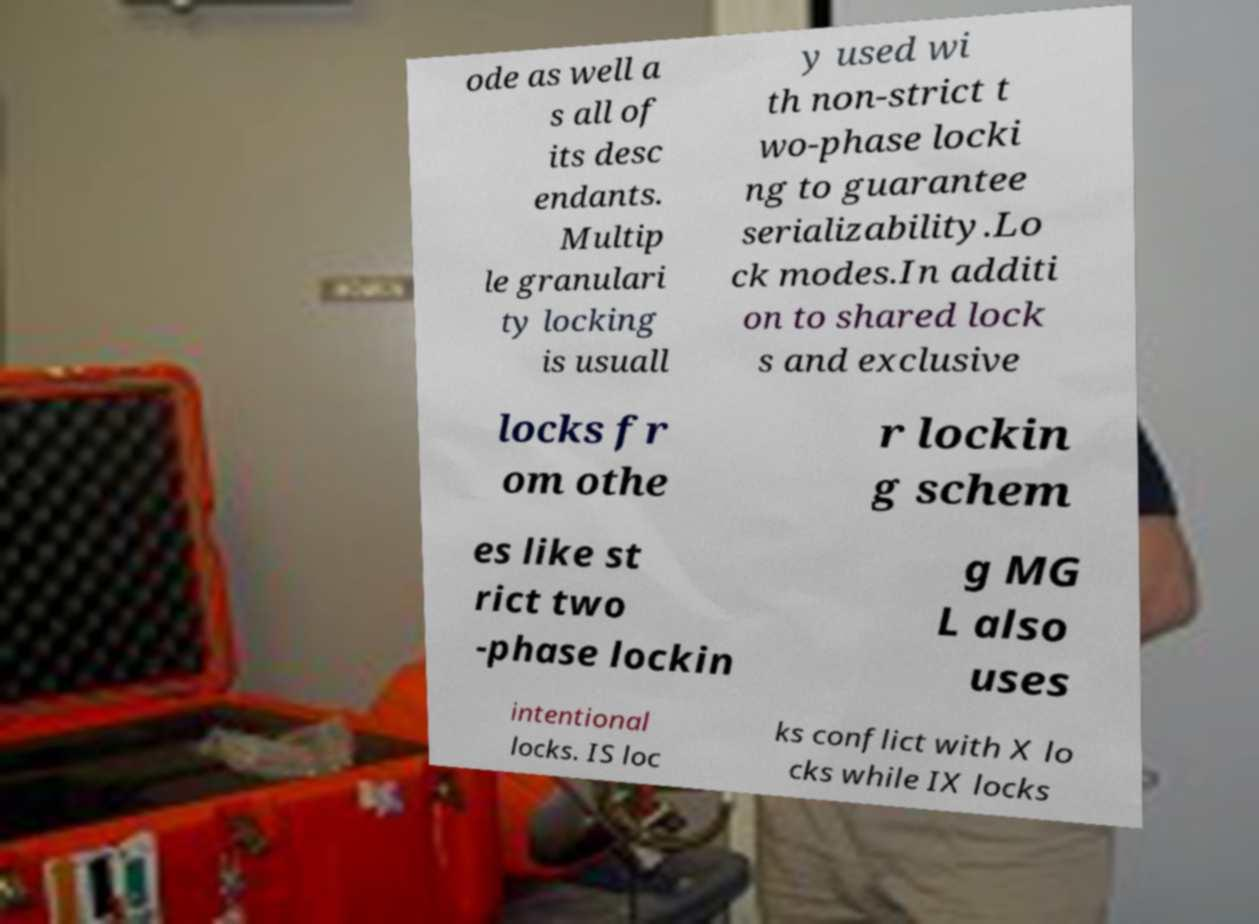For documentation purposes, I need the text within this image transcribed. Could you provide that? ode as well a s all of its desc endants. Multip le granulari ty locking is usuall y used wi th non-strict t wo-phase locki ng to guarantee serializability.Lo ck modes.In additi on to shared lock s and exclusive locks fr om othe r lockin g schem es like st rict two -phase lockin g MG L also uses intentional locks. IS loc ks conflict with X lo cks while IX locks 